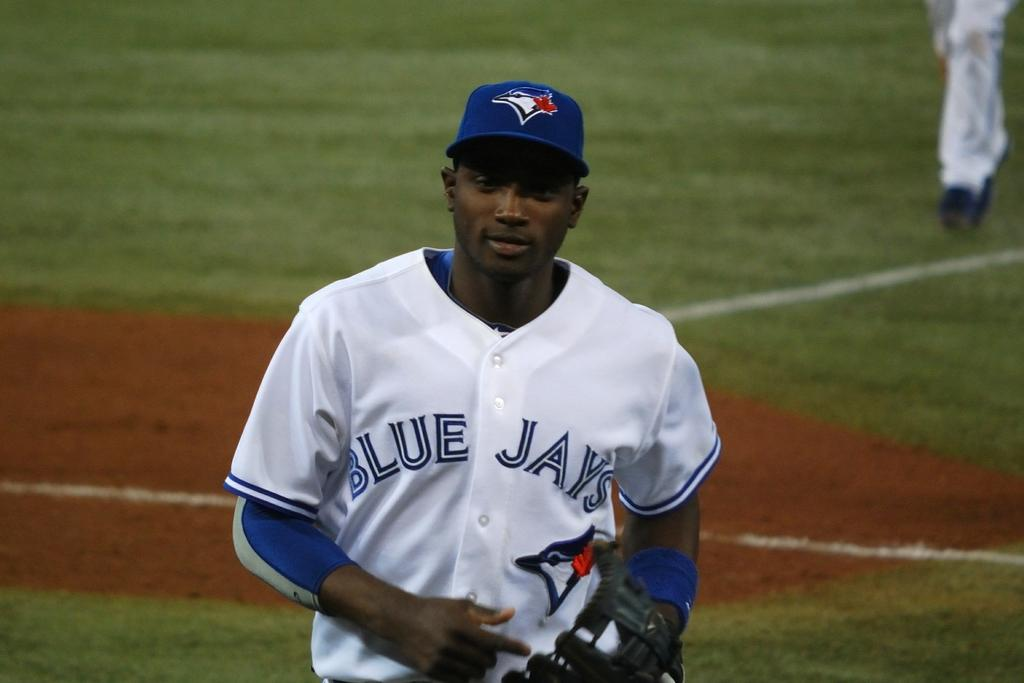<image>
Write a terse but informative summary of the picture. A Blue Jays baseball player on the field. 